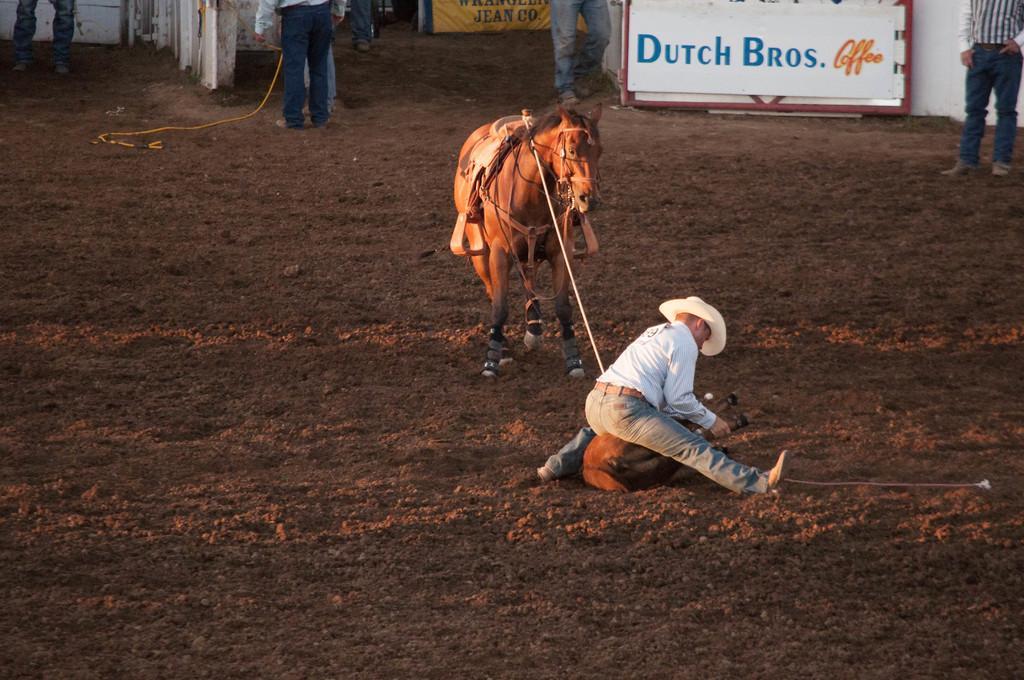How would you summarize this image in a sentence or two? In this image we can see a person sitting on the ground and holding a rope of the animal. We can also see some other persons standing and we can also see a board with some text. 